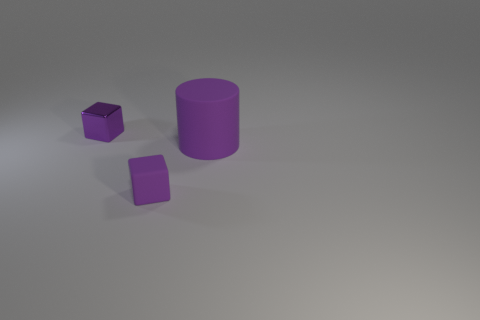Add 3 tiny gray metal cylinders. How many objects exist? 6 Subtract all cubes. How many objects are left? 1 Add 3 red metal cubes. How many red metal cubes exist? 3 Subtract 0 green cylinders. How many objects are left? 3 Subtract all tiny purple matte things. Subtract all purple metallic blocks. How many objects are left? 1 Add 2 small rubber blocks. How many small rubber blocks are left? 3 